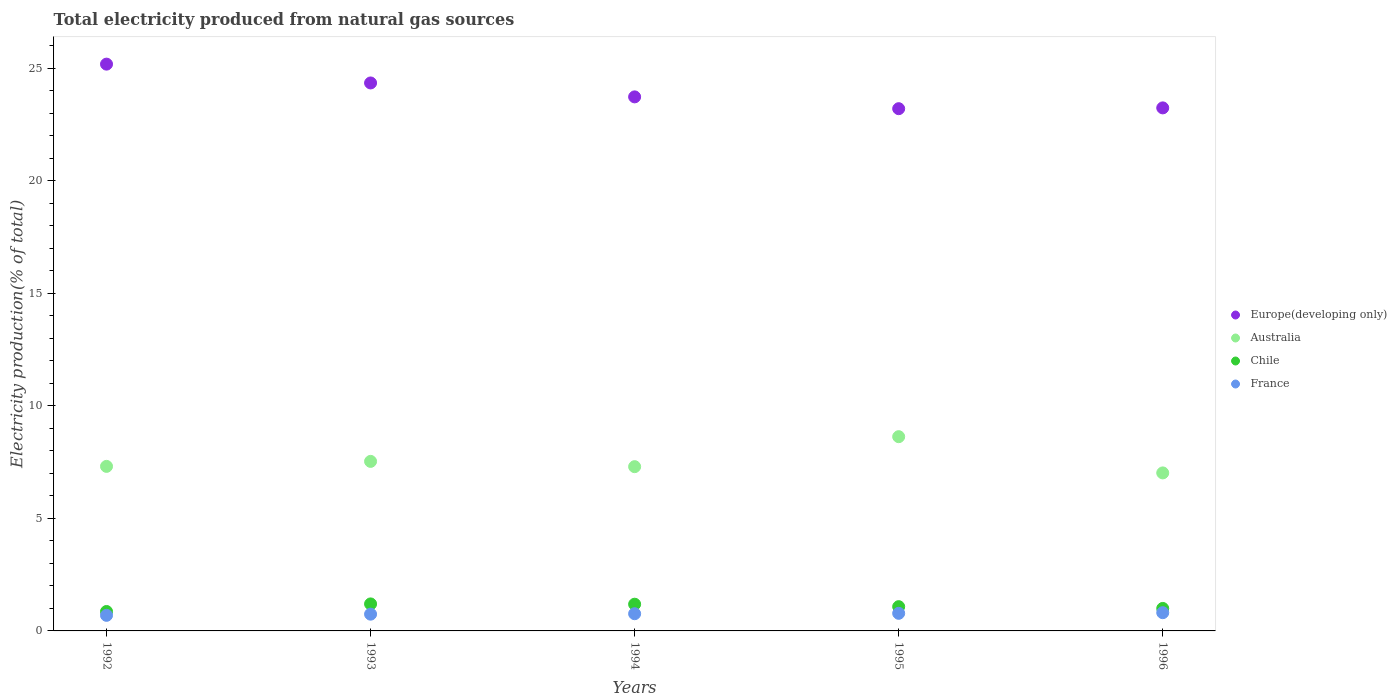How many different coloured dotlines are there?
Keep it short and to the point. 4. What is the total electricity produced in Europe(developing only) in 1995?
Ensure brevity in your answer.  23.2. Across all years, what is the maximum total electricity produced in France?
Make the answer very short. 0.81. Across all years, what is the minimum total electricity produced in Australia?
Provide a succinct answer. 7.02. What is the total total electricity produced in Europe(developing only) in the graph?
Offer a very short reply. 119.69. What is the difference between the total electricity produced in France in 1995 and that in 1996?
Offer a very short reply. -0.03. What is the difference between the total electricity produced in Europe(developing only) in 1992 and the total electricity produced in Australia in 1996?
Provide a short and direct response. 18.16. What is the average total electricity produced in Europe(developing only) per year?
Keep it short and to the point. 23.94. In the year 1995, what is the difference between the total electricity produced in Australia and total electricity produced in France?
Provide a succinct answer. 7.85. What is the ratio of the total electricity produced in Chile in 1992 to that in 1994?
Ensure brevity in your answer.  0.73. What is the difference between the highest and the second highest total electricity produced in Chile?
Your answer should be compact. 0.01. What is the difference between the highest and the lowest total electricity produced in Australia?
Make the answer very short. 1.61. In how many years, is the total electricity produced in Chile greater than the average total electricity produced in Chile taken over all years?
Your answer should be very brief. 3. Is it the case that in every year, the sum of the total electricity produced in Europe(developing only) and total electricity produced in France  is greater than the sum of total electricity produced in Chile and total electricity produced in Australia?
Your response must be concise. Yes. Is the total electricity produced in Europe(developing only) strictly less than the total electricity produced in Chile over the years?
Offer a terse response. No. What is the difference between two consecutive major ticks on the Y-axis?
Provide a short and direct response. 5. Are the values on the major ticks of Y-axis written in scientific E-notation?
Your answer should be compact. No. Does the graph contain any zero values?
Ensure brevity in your answer.  No. Does the graph contain grids?
Offer a very short reply. No. Where does the legend appear in the graph?
Offer a very short reply. Center right. What is the title of the graph?
Offer a terse response. Total electricity produced from natural gas sources. Does "Belarus" appear as one of the legend labels in the graph?
Keep it short and to the point. No. What is the label or title of the X-axis?
Give a very brief answer. Years. What is the Electricity production(% of total) in Europe(developing only) in 1992?
Your response must be concise. 25.18. What is the Electricity production(% of total) in Australia in 1992?
Provide a short and direct response. 7.31. What is the Electricity production(% of total) in Chile in 1992?
Offer a terse response. 0.86. What is the Electricity production(% of total) in France in 1992?
Your answer should be very brief. 0.69. What is the Electricity production(% of total) of Europe(developing only) in 1993?
Provide a short and direct response. 24.34. What is the Electricity production(% of total) in Australia in 1993?
Give a very brief answer. 7.53. What is the Electricity production(% of total) in Chile in 1993?
Provide a succinct answer. 1.2. What is the Electricity production(% of total) of France in 1993?
Give a very brief answer. 0.74. What is the Electricity production(% of total) in Europe(developing only) in 1994?
Your answer should be very brief. 23.73. What is the Electricity production(% of total) of Australia in 1994?
Ensure brevity in your answer.  7.3. What is the Electricity production(% of total) in Chile in 1994?
Your answer should be compact. 1.19. What is the Electricity production(% of total) of France in 1994?
Your response must be concise. 0.76. What is the Electricity production(% of total) of Europe(developing only) in 1995?
Provide a succinct answer. 23.2. What is the Electricity production(% of total) in Australia in 1995?
Keep it short and to the point. 8.63. What is the Electricity production(% of total) in Chile in 1995?
Provide a short and direct response. 1.08. What is the Electricity production(% of total) of France in 1995?
Your answer should be compact. 0.78. What is the Electricity production(% of total) of Europe(developing only) in 1996?
Your answer should be compact. 23.24. What is the Electricity production(% of total) of Australia in 1996?
Your response must be concise. 7.02. What is the Electricity production(% of total) of Chile in 1996?
Provide a short and direct response. 1. What is the Electricity production(% of total) of France in 1996?
Your answer should be very brief. 0.81. Across all years, what is the maximum Electricity production(% of total) in Europe(developing only)?
Provide a succinct answer. 25.18. Across all years, what is the maximum Electricity production(% of total) in Australia?
Make the answer very short. 8.63. Across all years, what is the maximum Electricity production(% of total) in Chile?
Provide a short and direct response. 1.2. Across all years, what is the maximum Electricity production(% of total) of France?
Make the answer very short. 0.81. Across all years, what is the minimum Electricity production(% of total) in Europe(developing only)?
Offer a terse response. 23.2. Across all years, what is the minimum Electricity production(% of total) of Australia?
Give a very brief answer. 7.02. Across all years, what is the minimum Electricity production(% of total) in Chile?
Make the answer very short. 0.86. Across all years, what is the minimum Electricity production(% of total) in France?
Give a very brief answer. 0.69. What is the total Electricity production(% of total) in Europe(developing only) in the graph?
Keep it short and to the point. 119.69. What is the total Electricity production(% of total) of Australia in the graph?
Your response must be concise. 37.79. What is the total Electricity production(% of total) in Chile in the graph?
Ensure brevity in your answer.  5.33. What is the total Electricity production(% of total) of France in the graph?
Make the answer very short. 3.79. What is the difference between the Electricity production(% of total) of Europe(developing only) in 1992 and that in 1993?
Ensure brevity in your answer.  0.84. What is the difference between the Electricity production(% of total) of Australia in 1992 and that in 1993?
Ensure brevity in your answer.  -0.22. What is the difference between the Electricity production(% of total) in Chile in 1992 and that in 1993?
Make the answer very short. -0.34. What is the difference between the Electricity production(% of total) in France in 1992 and that in 1993?
Ensure brevity in your answer.  -0.05. What is the difference between the Electricity production(% of total) in Europe(developing only) in 1992 and that in 1994?
Keep it short and to the point. 1.45. What is the difference between the Electricity production(% of total) of Australia in 1992 and that in 1994?
Keep it short and to the point. 0.01. What is the difference between the Electricity production(% of total) of Chile in 1992 and that in 1994?
Provide a short and direct response. -0.32. What is the difference between the Electricity production(% of total) in France in 1992 and that in 1994?
Your answer should be compact. -0.07. What is the difference between the Electricity production(% of total) of Europe(developing only) in 1992 and that in 1995?
Provide a succinct answer. 1.98. What is the difference between the Electricity production(% of total) in Australia in 1992 and that in 1995?
Offer a terse response. -1.32. What is the difference between the Electricity production(% of total) of Chile in 1992 and that in 1995?
Your answer should be compact. -0.21. What is the difference between the Electricity production(% of total) of France in 1992 and that in 1995?
Your response must be concise. -0.09. What is the difference between the Electricity production(% of total) in Europe(developing only) in 1992 and that in 1996?
Provide a short and direct response. 1.94. What is the difference between the Electricity production(% of total) of Australia in 1992 and that in 1996?
Your response must be concise. 0.29. What is the difference between the Electricity production(% of total) of Chile in 1992 and that in 1996?
Offer a very short reply. -0.14. What is the difference between the Electricity production(% of total) in France in 1992 and that in 1996?
Provide a short and direct response. -0.12. What is the difference between the Electricity production(% of total) of Europe(developing only) in 1993 and that in 1994?
Provide a short and direct response. 0.62. What is the difference between the Electricity production(% of total) of Australia in 1993 and that in 1994?
Your response must be concise. 0.23. What is the difference between the Electricity production(% of total) of Chile in 1993 and that in 1994?
Ensure brevity in your answer.  0.01. What is the difference between the Electricity production(% of total) in France in 1993 and that in 1994?
Make the answer very short. -0.02. What is the difference between the Electricity production(% of total) of Europe(developing only) in 1993 and that in 1995?
Give a very brief answer. 1.14. What is the difference between the Electricity production(% of total) of Australia in 1993 and that in 1995?
Offer a terse response. -1.1. What is the difference between the Electricity production(% of total) in Chile in 1993 and that in 1995?
Provide a succinct answer. 0.12. What is the difference between the Electricity production(% of total) of France in 1993 and that in 1995?
Provide a succinct answer. -0.04. What is the difference between the Electricity production(% of total) of Europe(developing only) in 1993 and that in 1996?
Give a very brief answer. 1.11. What is the difference between the Electricity production(% of total) in Australia in 1993 and that in 1996?
Offer a terse response. 0.51. What is the difference between the Electricity production(% of total) in Chile in 1993 and that in 1996?
Keep it short and to the point. 0.2. What is the difference between the Electricity production(% of total) of France in 1993 and that in 1996?
Keep it short and to the point. -0.07. What is the difference between the Electricity production(% of total) in Europe(developing only) in 1994 and that in 1995?
Your answer should be very brief. 0.52. What is the difference between the Electricity production(% of total) of Australia in 1994 and that in 1995?
Offer a terse response. -1.33. What is the difference between the Electricity production(% of total) in Chile in 1994 and that in 1995?
Provide a succinct answer. 0.11. What is the difference between the Electricity production(% of total) in France in 1994 and that in 1995?
Offer a very short reply. -0.02. What is the difference between the Electricity production(% of total) of Europe(developing only) in 1994 and that in 1996?
Your response must be concise. 0.49. What is the difference between the Electricity production(% of total) in Australia in 1994 and that in 1996?
Give a very brief answer. 0.28. What is the difference between the Electricity production(% of total) in Chile in 1994 and that in 1996?
Your answer should be compact. 0.19. What is the difference between the Electricity production(% of total) of France in 1994 and that in 1996?
Offer a terse response. -0.05. What is the difference between the Electricity production(% of total) in Europe(developing only) in 1995 and that in 1996?
Keep it short and to the point. -0.04. What is the difference between the Electricity production(% of total) of Australia in 1995 and that in 1996?
Provide a short and direct response. 1.61. What is the difference between the Electricity production(% of total) in Chile in 1995 and that in 1996?
Your answer should be compact. 0.08. What is the difference between the Electricity production(% of total) of France in 1995 and that in 1996?
Offer a very short reply. -0.03. What is the difference between the Electricity production(% of total) of Europe(developing only) in 1992 and the Electricity production(% of total) of Australia in 1993?
Your answer should be very brief. 17.65. What is the difference between the Electricity production(% of total) of Europe(developing only) in 1992 and the Electricity production(% of total) of Chile in 1993?
Your answer should be very brief. 23.98. What is the difference between the Electricity production(% of total) in Europe(developing only) in 1992 and the Electricity production(% of total) in France in 1993?
Make the answer very short. 24.44. What is the difference between the Electricity production(% of total) in Australia in 1992 and the Electricity production(% of total) in Chile in 1993?
Make the answer very short. 6.11. What is the difference between the Electricity production(% of total) of Australia in 1992 and the Electricity production(% of total) of France in 1993?
Your answer should be very brief. 6.57. What is the difference between the Electricity production(% of total) in Chile in 1992 and the Electricity production(% of total) in France in 1993?
Keep it short and to the point. 0.12. What is the difference between the Electricity production(% of total) of Europe(developing only) in 1992 and the Electricity production(% of total) of Australia in 1994?
Ensure brevity in your answer.  17.88. What is the difference between the Electricity production(% of total) of Europe(developing only) in 1992 and the Electricity production(% of total) of Chile in 1994?
Your response must be concise. 23.99. What is the difference between the Electricity production(% of total) in Europe(developing only) in 1992 and the Electricity production(% of total) in France in 1994?
Make the answer very short. 24.42. What is the difference between the Electricity production(% of total) of Australia in 1992 and the Electricity production(% of total) of Chile in 1994?
Keep it short and to the point. 6.12. What is the difference between the Electricity production(% of total) of Australia in 1992 and the Electricity production(% of total) of France in 1994?
Your answer should be compact. 6.55. What is the difference between the Electricity production(% of total) in Chile in 1992 and the Electricity production(% of total) in France in 1994?
Make the answer very short. 0.1. What is the difference between the Electricity production(% of total) of Europe(developing only) in 1992 and the Electricity production(% of total) of Australia in 1995?
Your response must be concise. 16.55. What is the difference between the Electricity production(% of total) of Europe(developing only) in 1992 and the Electricity production(% of total) of Chile in 1995?
Give a very brief answer. 24.1. What is the difference between the Electricity production(% of total) of Europe(developing only) in 1992 and the Electricity production(% of total) of France in 1995?
Your answer should be very brief. 24.4. What is the difference between the Electricity production(% of total) in Australia in 1992 and the Electricity production(% of total) in Chile in 1995?
Provide a succinct answer. 6.23. What is the difference between the Electricity production(% of total) in Australia in 1992 and the Electricity production(% of total) in France in 1995?
Your answer should be very brief. 6.53. What is the difference between the Electricity production(% of total) in Chile in 1992 and the Electricity production(% of total) in France in 1995?
Your response must be concise. 0.08. What is the difference between the Electricity production(% of total) in Europe(developing only) in 1992 and the Electricity production(% of total) in Australia in 1996?
Give a very brief answer. 18.16. What is the difference between the Electricity production(% of total) of Europe(developing only) in 1992 and the Electricity production(% of total) of Chile in 1996?
Ensure brevity in your answer.  24.18. What is the difference between the Electricity production(% of total) in Europe(developing only) in 1992 and the Electricity production(% of total) in France in 1996?
Provide a short and direct response. 24.37. What is the difference between the Electricity production(% of total) of Australia in 1992 and the Electricity production(% of total) of Chile in 1996?
Offer a terse response. 6.31. What is the difference between the Electricity production(% of total) in Australia in 1992 and the Electricity production(% of total) in France in 1996?
Offer a terse response. 6.5. What is the difference between the Electricity production(% of total) in Chile in 1992 and the Electricity production(% of total) in France in 1996?
Offer a terse response. 0.05. What is the difference between the Electricity production(% of total) in Europe(developing only) in 1993 and the Electricity production(% of total) in Australia in 1994?
Your response must be concise. 17.05. What is the difference between the Electricity production(% of total) of Europe(developing only) in 1993 and the Electricity production(% of total) of Chile in 1994?
Give a very brief answer. 23.16. What is the difference between the Electricity production(% of total) in Europe(developing only) in 1993 and the Electricity production(% of total) in France in 1994?
Keep it short and to the point. 23.58. What is the difference between the Electricity production(% of total) of Australia in 1993 and the Electricity production(% of total) of Chile in 1994?
Your answer should be compact. 6.35. What is the difference between the Electricity production(% of total) of Australia in 1993 and the Electricity production(% of total) of France in 1994?
Your response must be concise. 6.77. What is the difference between the Electricity production(% of total) of Chile in 1993 and the Electricity production(% of total) of France in 1994?
Your response must be concise. 0.44. What is the difference between the Electricity production(% of total) of Europe(developing only) in 1993 and the Electricity production(% of total) of Australia in 1995?
Your answer should be compact. 15.71. What is the difference between the Electricity production(% of total) in Europe(developing only) in 1993 and the Electricity production(% of total) in Chile in 1995?
Your answer should be compact. 23.27. What is the difference between the Electricity production(% of total) in Europe(developing only) in 1993 and the Electricity production(% of total) in France in 1995?
Provide a succinct answer. 23.56. What is the difference between the Electricity production(% of total) of Australia in 1993 and the Electricity production(% of total) of Chile in 1995?
Offer a very short reply. 6.45. What is the difference between the Electricity production(% of total) in Australia in 1993 and the Electricity production(% of total) in France in 1995?
Keep it short and to the point. 6.75. What is the difference between the Electricity production(% of total) in Chile in 1993 and the Electricity production(% of total) in France in 1995?
Your response must be concise. 0.42. What is the difference between the Electricity production(% of total) in Europe(developing only) in 1993 and the Electricity production(% of total) in Australia in 1996?
Your answer should be very brief. 17.32. What is the difference between the Electricity production(% of total) of Europe(developing only) in 1993 and the Electricity production(% of total) of Chile in 1996?
Keep it short and to the point. 23.35. What is the difference between the Electricity production(% of total) in Europe(developing only) in 1993 and the Electricity production(% of total) in France in 1996?
Offer a terse response. 23.54. What is the difference between the Electricity production(% of total) in Australia in 1993 and the Electricity production(% of total) in Chile in 1996?
Offer a terse response. 6.53. What is the difference between the Electricity production(% of total) in Australia in 1993 and the Electricity production(% of total) in France in 1996?
Provide a short and direct response. 6.72. What is the difference between the Electricity production(% of total) in Chile in 1993 and the Electricity production(% of total) in France in 1996?
Keep it short and to the point. 0.39. What is the difference between the Electricity production(% of total) of Europe(developing only) in 1994 and the Electricity production(% of total) of Australia in 1995?
Provide a succinct answer. 15.1. What is the difference between the Electricity production(% of total) of Europe(developing only) in 1994 and the Electricity production(% of total) of Chile in 1995?
Provide a short and direct response. 22.65. What is the difference between the Electricity production(% of total) in Europe(developing only) in 1994 and the Electricity production(% of total) in France in 1995?
Provide a short and direct response. 22.94. What is the difference between the Electricity production(% of total) in Australia in 1994 and the Electricity production(% of total) in Chile in 1995?
Provide a succinct answer. 6.22. What is the difference between the Electricity production(% of total) of Australia in 1994 and the Electricity production(% of total) of France in 1995?
Provide a succinct answer. 6.52. What is the difference between the Electricity production(% of total) of Chile in 1994 and the Electricity production(% of total) of France in 1995?
Give a very brief answer. 0.41. What is the difference between the Electricity production(% of total) in Europe(developing only) in 1994 and the Electricity production(% of total) in Australia in 1996?
Offer a terse response. 16.71. What is the difference between the Electricity production(% of total) in Europe(developing only) in 1994 and the Electricity production(% of total) in Chile in 1996?
Ensure brevity in your answer.  22.73. What is the difference between the Electricity production(% of total) of Europe(developing only) in 1994 and the Electricity production(% of total) of France in 1996?
Give a very brief answer. 22.92. What is the difference between the Electricity production(% of total) of Australia in 1994 and the Electricity production(% of total) of Chile in 1996?
Give a very brief answer. 6.3. What is the difference between the Electricity production(% of total) in Australia in 1994 and the Electricity production(% of total) in France in 1996?
Your response must be concise. 6.49. What is the difference between the Electricity production(% of total) in Chile in 1994 and the Electricity production(% of total) in France in 1996?
Make the answer very short. 0.38. What is the difference between the Electricity production(% of total) of Europe(developing only) in 1995 and the Electricity production(% of total) of Australia in 1996?
Provide a short and direct response. 16.18. What is the difference between the Electricity production(% of total) in Europe(developing only) in 1995 and the Electricity production(% of total) in Chile in 1996?
Keep it short and to the point. 22.2. What is the difference between the Electricity production(% of total) of Europe(developing only) in 1995 and the Electricity production(% of total) of France in 1996?
Your answer should be compact. 22.39. What is the difference between the Electricity production(% of total) of Australia in 1995 and the Electricity production(% of total) of Chile in 1996?
Offer a terse response. 7.63. What is the difference between the Electricity production(% of total) of Australia in 1995 and the Electricity production(% of total) of France in 1996?
Your response must be concise. 7.82. What is the difference between the Electricity production(% of total) in Chile in 1995 and the Electricity production(% of total) in France in 1996?
Ensure brevity in your answer.  0.27. What is the average Electricity production(% of total) of Europe(developing only) per year?
Provide a short and direct response. 23.94. What is the average Electricity production(% of total) in Australia per year?
Keep it short and to the point. 7.56. What is the average Electricity production(% of total) of Chile per year?
Your answer should be very brief. 1.07. What is the average Electricity production(% of total) in France per year?
Your response must be concise. 0.76. In the year 1992, what is the difference between the Electricity production(% of total) of Europe(developing only) and Electricity production(% of total) of Australia?
Your response must be concise. 17.87. In the year 1992, what is the difference between the Electricity production(% of total) in Europe(developing only) and Electricity production(% of total) in Chile?
Offer a very short reply. 24.32. In the year 1992, what is the difference between the Electricity production(% of total) in Europe(developing only) and Electricity production(% of total) in France?
Your answer should be very brief. 24.49. In the year 1992, what is the difference between the Electricity production(% of total) in Australia and Electricity production(% of total) in Chile?
Offer a very short reply. 6.45. In the year 1992, what is the difference between the Electricity production(% of total) of Australia and Electricity production(% of total) of France?
Ensure brevity in your answer.  6.62. In the year 1992, what is the difference between the Electricity production(% of total) of Chile and Electricity production(% of total) of France?
Provide a short and direct response. 0.17. In the year 1993, what is the difference between the Electricity production(% of total) of Europe(developing only) and Electricity production(% of total) of Australia?
Your response must be concise. 16.81. In the year 1993, what is the difference between the Electricity production(% of total) in Europe(developing only) and Electricity production(% of total) in Chile?
Offer a very short reply. 23.15. In the year 1993, what is the difference between the Electricity production(% of total) in Europe(developing only) and Electricity production(% of total) in France?
Offer a very short reply. 23.6. In the year 1993, what is the difference between the Electricity production(% of total) in Australia and Electricity production(% of total) in Chile?
Give a very brief answer. 6.33. In the year 1993, what is the difference between the Electricity production(% of total) of Australia and Electricity production(% of total) of France?
Offer a terse response. 6.79. In the year 1993, what is the difference between the Electricity production(% of total) in Chile and Electricity production(% of total) in France?
Keep it short and to the point. 0.46. In the year 1994, what is the difference between the Electricity production(% of total) in Europe(developing only) and Electricity production(% of total) in Australia?
Offer a very short reply. 16.43. In the year 1994, what is the difference between the Electricity production(% of total) of Europe(developing only) and Electricity production(% of total) of Chile?
Your response must be concise. 22.54. In the year 1994, what is the difference between the Electricity production(% of total) of Europe(developing only) and Electricity production(% of total) of France?
Give a very brief answer. 22.96. In the year 1994, what is the difference between the Electricity production(% of total) in Australia and Electricity production(% of total) in Chile?
Provide a succinct answer. 6.11. In the year 1994, what is the difference between the Electricity production(% of total) in Australia and Electricity production(% of total) in France?
Give a very brief answer. 6.53. In the year 1994, what is the difference between the Electricity production(% of total) in Chile and Electricity production(% of total) in France?
Make the answer very short. 0.42. In the year 1995, what is the difference between the Electricity production(% of total) of Europe(developing only) and Electricity production(% of total) of Australia?
Ensure brevity in your answer.  14.57. In the year 1995, what is the difference between the Electricity production(% of total) of Europe(developing only) and Electricity production(% of total) of Chile?
Offer a very short reply. 22.12. In the year 1995, what is the difference between the Electricity production(% of total) in Europe(developing only) and Electricity production(% of total) in France?
Keep it short and to the point. 22.42. In the year 1995, what is the difference between the Electricity production(% of total) of Australia and Electricity production(% of total) of Chile?
Your response must be concise. 7.55. In the year 1995, what is the difference between the Electricity production(% of total) in Australia and Electricity production(% of total) in France?
Provide a succinct answer. 7.85. In the year 1995, what is the difference between the Electricity production(% of total) of Chile and Electricity production(% of total) of France?
Offer a terse response. 0.3. In the year 1996, what is the difference between the Electricity production(% of total) of Europe(developing only) and Electricity production(% of total) of Australia?
Your response must be concise. 16.22. In the year 1996, what is the difference between the Electricity production(% of total) of Europe(developing only) and Electricity production(% of total) of Chile?
Offer a terse response. 22.24. In the year 1996, what is the difference between the Electricity production(% of total) of Europe(developing only) and Electricity production(% of total) of France?
Offer a terse response. 22.43. In the year 1996, what is the difference between the Electricity production(% of total) of Australia and Electricity production(% of total) of Chile?
Your answer should be very brief. 6.02. In the year 1996, what is the difference between the Electricity production(% of total) in Australia and Electricity production(% of total) in France?
Ensure brevity in your answer.  6.21. In the year 1996, what is the difference between the Electricity production(% of total) of Chile and Electricity production(% of total) of France?
Make the answer very short. 0.19. What is the ratio of the Electricity production(% of total) of Europe(developing only) in 1992 to that in 1993?
Provide a short and direct response. 1.03. What is the ratio of the Electricity production(% of total) of Australia in 1992 to that in 1993?
Provide a succinct answer. 0.97. What is the ratio of the Electricity production(% of total) in Chile in 1992 to that in 1993?
Give a very brief answer. 0.72. What is the ratio of the Electricity production(% of total) in France in 1992 to that in 1993?
Keep it short and to the point. 0.93. What is the ratio of the Electricity production(% of total) in Europe(developing only) in 1992 to that in 1994?
Provide a short and direct response. 1.06. What is the ratio of the Electricity production(% of total) of Australia in 1992 to that in 1994?
Your response must be concise. 1. What is the ratio of the Electricity production(% of total) of Chile in 1992 to that in 1994?
Ensure brevity in your answer.  0.73. What is the ratio of the Electricity production(% of total) of France in 1992 to that in 1994?
Provide a short and direct response. 0.91. What is the ratio of the Electricity production(% of total) of Europe(developing only) in 1992 to that in 1995?
Your answer should be compact. 1.09. What is the ratio of the Electricity production(% of total) in Australia in 1992 to that in 1995?
Your answer should be very brief. 0.85. What is the ratio of the Electricity production(% of total) of Chile in 1992 to that in 1995?
Provide a short and direct response. 0.8. What is the ratio of the Electricity production(% of total) of France in 1992 to that in 1995?
Provide a succinct answer. 0.89. What is the ratio of the Electricity production(% of total) of Europe(developing only) in 1992 to that in 1996?
Provide a succinct answer. 1.08. What is the ratio of the Electricity production(% of total) in Australia in 1992 to that in 1996?
Provide a succinct answer. 1.04. What is the ratio of the Electricity production(% of total) in Chile in 1992 to that in 1996?
Provide a short and direct response. 0.86. What is the ratio of the Electricity production(% of total) in France in 1992 to that in 1996?
Provide a short and direct response. 0.86. What is the ratio of the Electricity production(% of total) in Europe(developing only) in 1993 to that in 1994?
Provide a succinct answer. 1.03. What is the ratio of the Electricity production(% of total) of Australia in 1993 to that in 1994?
Make the answer very short. 1.03. What is the ratio of the Electricity production(% of total) of Chile in 1993 to that in 1994?
Provide a succinct answer. 1.01. What is the ratio of the Electricity production(% of total) in France in 1993 to that in 1994?
Your answer should be very brief. 0.97. What is the ratio of the Electricity production(% of total) of Europe(developing only) in 1993 to that in 1995?
Your answer should be compact. 1.05. What is the ratio of the Electricity production(% of total) in Australia in 1993 to that in 1995?
Ensure brevity in your answer.  0.87. What is the ratio of the Electricity production(% of total) in Chile in 1993 to that in 1995?
Make the answer very short. 1.11. What is the ratio of the Electricity production(% of total) of France in 1993 to that in 1995?
Your answer should be very brief. 0.95. What is the ratio of the Electricity production(% of total) in Europe(developing only) in 1993 to that in 1996?
Provide a short and direct response. 1.05. What is the ratio of the Electricity production(% of total) of Australia in 1993 to that in 1996?
Your answer should be compact. 1.07. What is the ratio of the Electricity production(% of total) in Chile in 1993 to that in 1996?
Your answer should be very brief. 1.2. What is the ratio of the Electricity production(% of total) of France in 1993 to that in 1996?
Your answer should be very brief. 0.92. What is the ratio of the Electricity production(% of total) of Europe(developing only) in 1994 to that in 1995?
Ensure brevity in your answer.  1.02. What is the ratio of the Electricity production(% of total) of Australia in 1994 to that in 1995?
Provide a short and direct response. 0.85. What is the ratio of the Electricity production(% of total) of Chile in 1994 to that in 1995?
Offer a very short reply. 1.1. What is the ratio of the Electricity production(% of total) of France in 1994 to that in 1995?
Your answer should be compact. 0.98. What is the ratio of the Electricity production(% of total) in Europe(developing only) in 1994 to that in 1996?
Your answer should be very brief. 1.02. What is the ratio of the Electricity production(% of total) in Australia in 1994 to that in 1996?
Offer a terse response. 1.04. What is the ratio of the Electricity production(% of total) in Chile in 1994 to that in 1996?
Ensure brevity in your answer.  1.19. What is the ratio of the Electricity production(% of total) of France in 1994 to that in 1996?
Keep it short and to the point. 0.94. What is the ratio of the Electricity production(% of total) in Europe(developing only) in 1995 to that in 1996?
Your answer should be very brief. 1. What is the ratio of the Electricity production(% of total) in Australia in 1995 to that in 1996?
Provide a short and direct response. 1.23. What is the ratio of the Electricity production(% of total) in Chile in 1995 to that in 1996?
Your response must be concise. 1.08. What is the ratio of the Electricity production(% of total) of France in 1995 to that in 1996?
Provide a short and direct response. 0.97. What is the difference between the highest and the second highest Electricity production(% of total) in Europe(developing only)?
Give a very brief answer. 0.84. What is the difference between the highest and the second highest Electricity production(% of total) of Australia?
Give a very brief answer. 1.1. What is the difference between the highest and the second highest Electricity production(% of total) of Chile?
Provide a succinct answer. 0.01. What is the difference between the highest and the second highest Electricity production(% of total) in France?
Your answer should be very brief. 0.03. What is the difference between the highest and the lowest Electricity production(% of total) in Europe(developing only)?
Provide a short and direct response. 1.98. What is the difference between the highest and the lowest Electricity production(% of total) in Australia?
Your response must be concise. 1.61. What is the difference between the highest and the lowest Electricity production(% of total) in Chile?
Your response must be concise. 0.34. What is the difference between the highest and the lowest Electricity production(% of total) in France?
Make the answer very short. 0.12. 